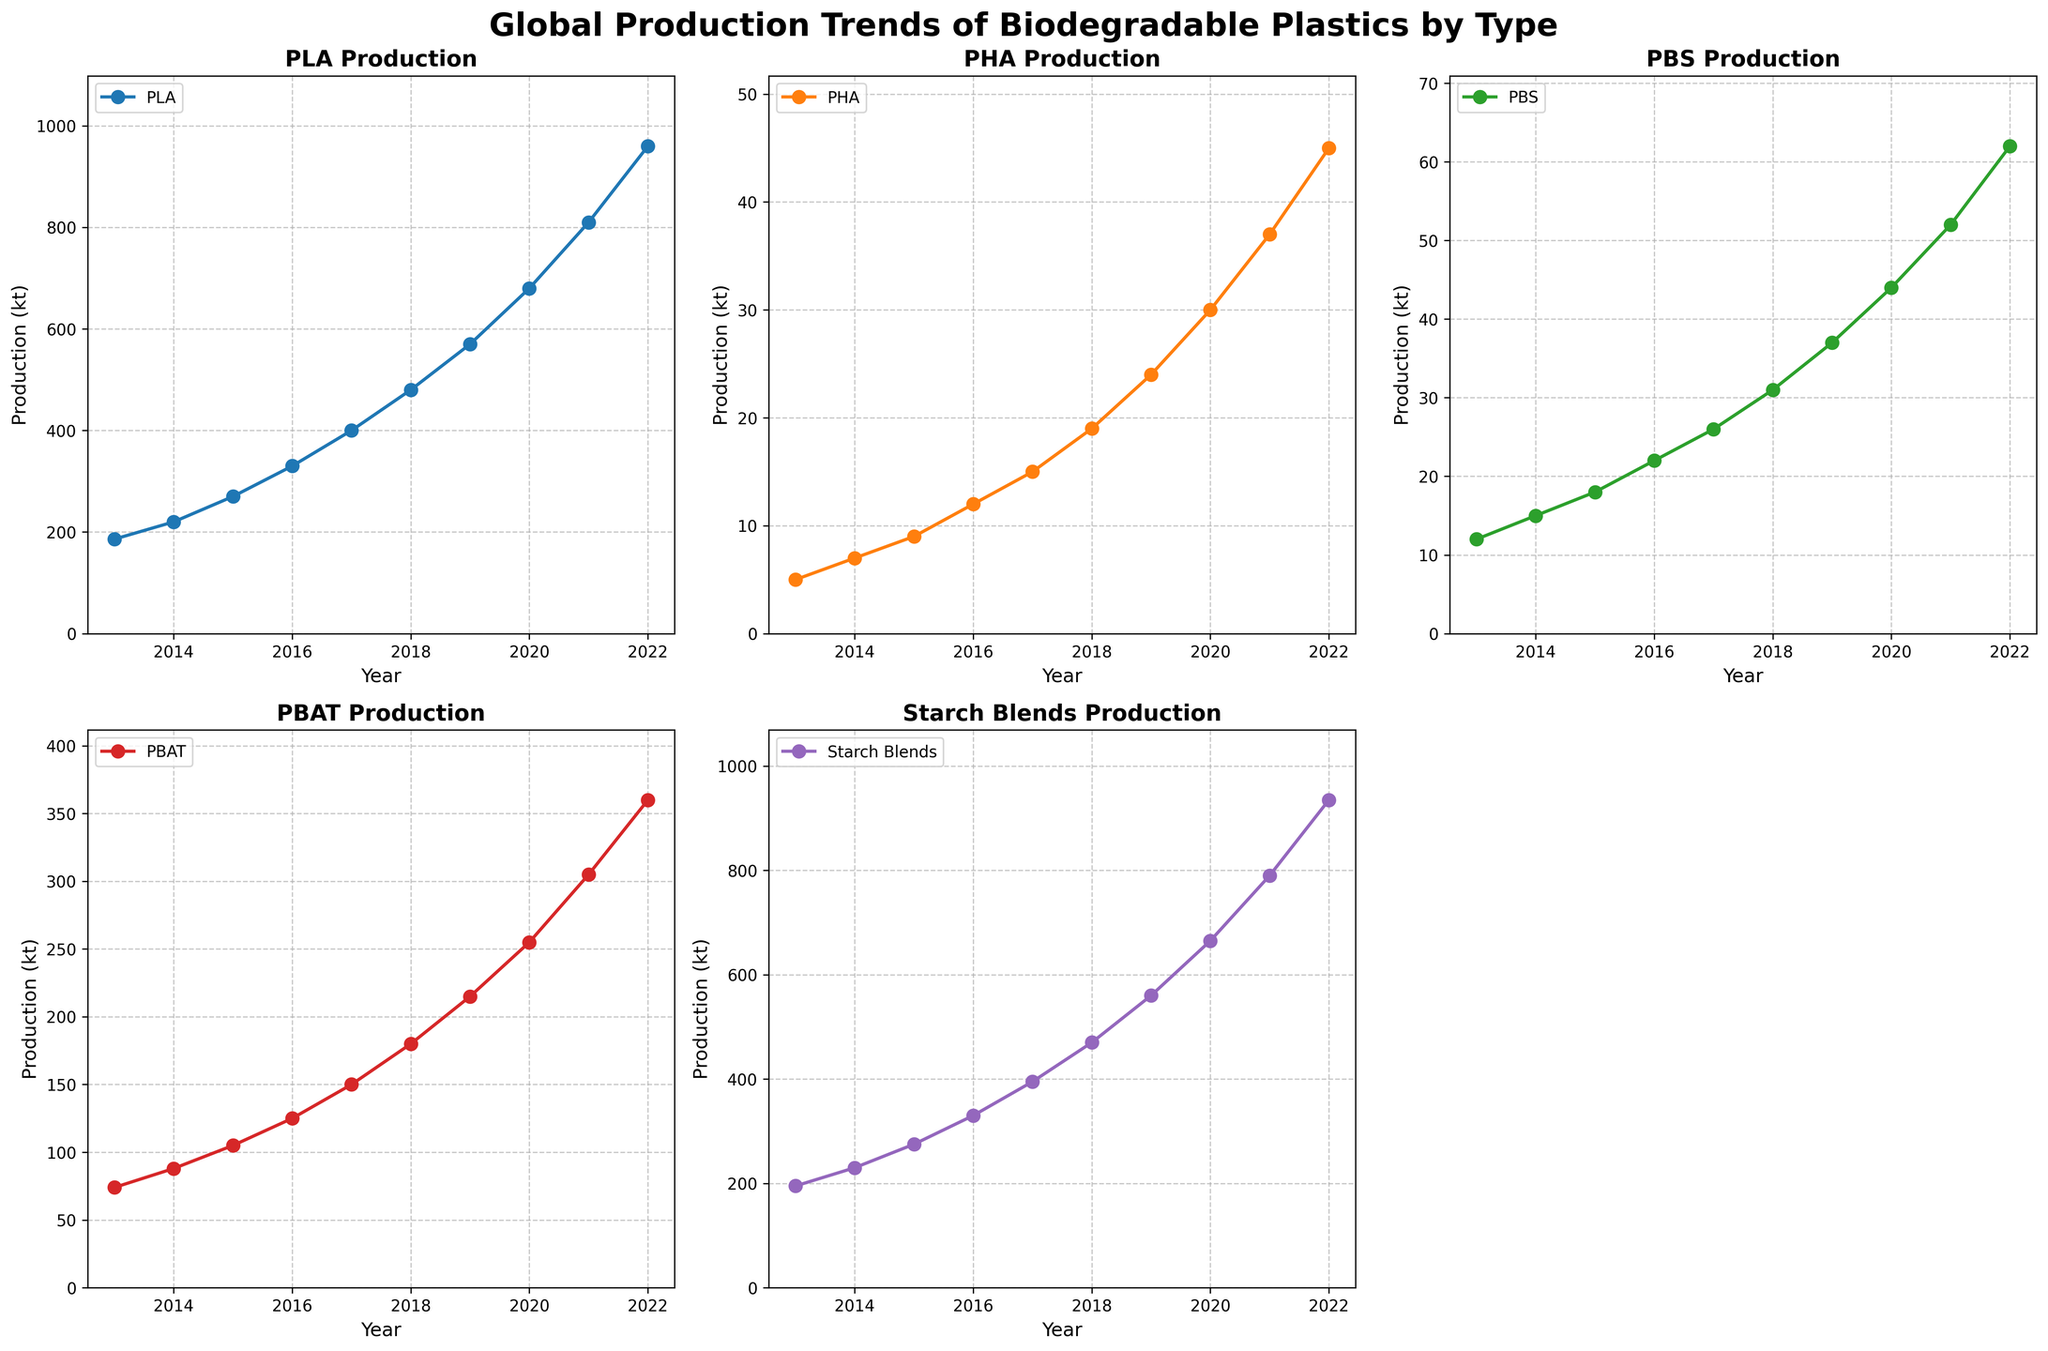What is the title of the plot? The title is at the top of the plot, and it reads "Global Production Trends of Biodegradable Plastics by Type".
Answer: Global Production Trends of Biodegradable Plastics by Type How many subplots are there, and which subplot is empty? There are 6 subplots in total, with 5 containing data on five types of biodegradable plastics, and the last one is empty. The empty subplot is in the second row, third column.
Answer: 6, the empty one is in the second row, third column What is the peak production value for PHA and in which year does it occur? By looking at the PHA subplot, the highest point on the line represents the peak. It occurs in 2022 with a value of 45 kt.
Answer: 45 kt in 2022 By how much did the production of PBAT increase from 2013 to 2022? Refer to the PBAT subplot to see the values for 2013 and 2022. The production increased from 74 kt to 360 kt. The difference is 360 - 74 = 286 kt.
Answer: 286 kt Which material shows the steepest increase in production over the decade? The steepest increase is observed visually by comparing the slopes of the lines across all subplots. PLA shows a continuous and steep increase in production, especially towards the later years.
Answer: PLA What is the total production of biodegradable plastics in 2020 from all types shown in the subplots? Sum up the values from the year 2020 for each material: PLA (680) + PHA (30) + PBS (44) + PBAT (255) + Starch Blends (665) = 1674 kt.
Answer: 1674 kt Which material had the least production in 2015? From the year 2015 in each subplot, PHA has the lowest production value, which is 9 kt.
Answer: PHA Between which years did Starch Blends see the largest increase in production? By looking at the Starch Blends subplot, the difference between consecutive years is highest between 2020 (665 kt) and 2021 (790 kt), giving an increase of 125 kt.
Answer: 2020 and 2021 